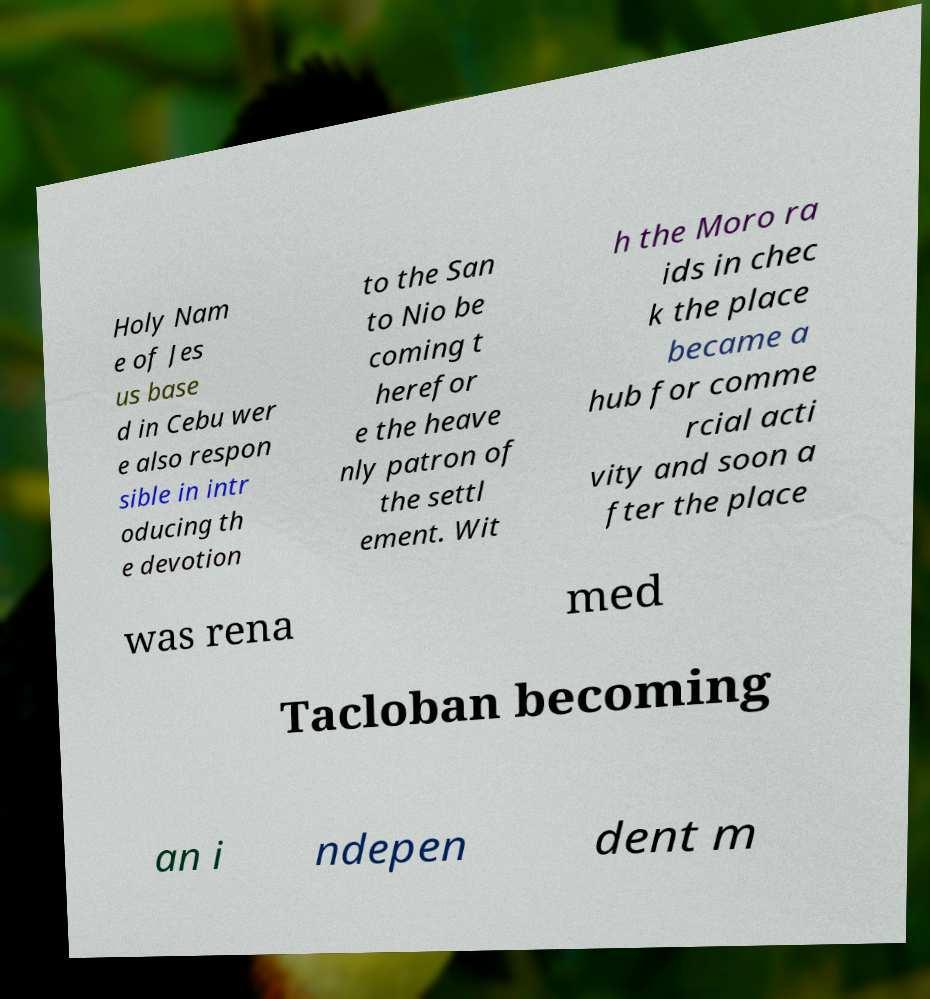Please read and relay the text visible in this image. What does it say? Holy Nam e of Jes us base d in Cebu wer e also respon sible in intr oducing th e devotion to the San to Nio be coming t herefor e the heave nly patron of the settl ement. Wit h the Moro ra ids in chec k the place became a hub for comme rcial acti vity and soon a fter the place was rena med Tacloban becoming an i ndepen dent m 